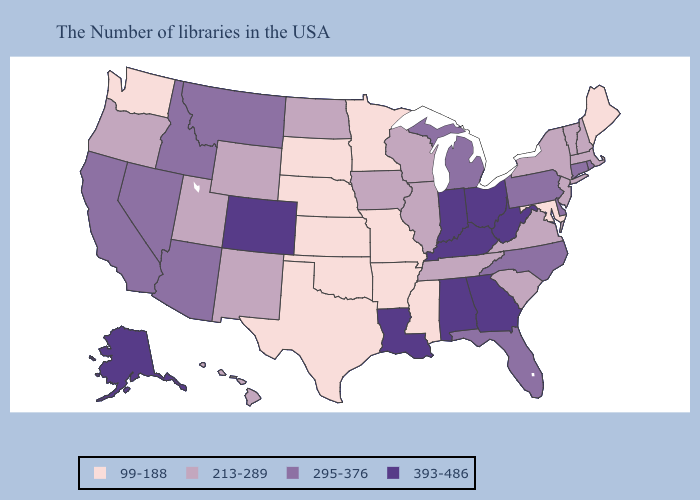Does the map have missing data?
Write a very short answer. No. Name the states that have a value in the range 295-376?
Concise answer only. Rhode Island, Connecticut, Delaware, Pennsylvania, North Carolina, Florida, Michigan, Montana, Arizona, Idaho, Nevada, California. What is the highest value in states that border Oklahoma?
Short answer required. 393-486. Does the map have missing data?
Short answer required. No. What is the lowest value in the Northeast?
Answer briefly. 99-188. What is the value of New Mexico?
Write a very short answer. 213-289. Name the states that have a value in the range 393-486?
Answer briefly. West Virginia, Ohio, Georgia, Kentucky, Indiana, Alabama, Louisiana, Colorado, Alaska. What is the highest value in states that border Minnesota?
Keep it brief. 213-289. What is the highest value in the South ?
Quick response, please. 393-486. Among the states that border Ohio , which have the lowest value?
Concise answer only. Pennsylvania, Michigan. Does the first symbol in the legend represent the smallest category?
Quick response, please. Yes. Does Rhode Island have the highest value in the Northeast?
Answer briefly. Yes. Name the states that have a value in the range 295-376?
Quick response, please. Rhode Island, Connecticut, Delaware, Pennsylvania, North Carolina, Florida, Michigan, Montana, Arizona, Idaho, Nevada, California. Does Kentucky have the highest value in the USA?
Short answer required. Yes. 